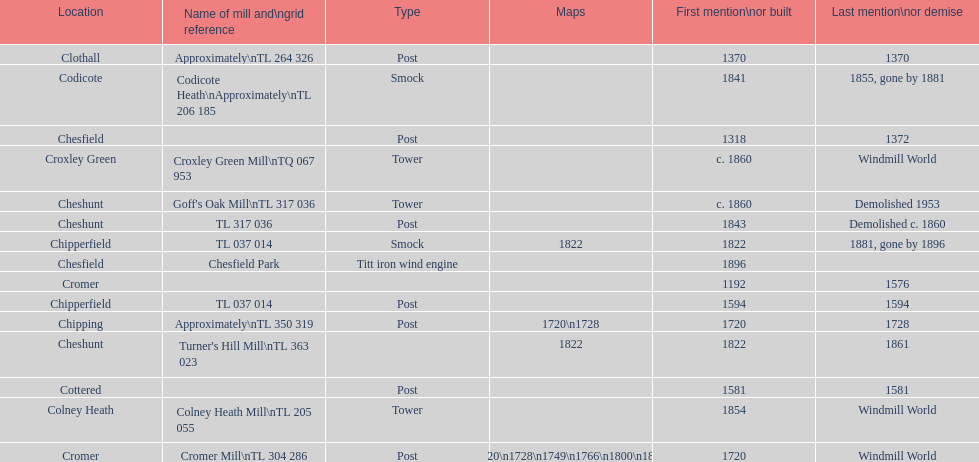What location has the most maps? Cromer. 